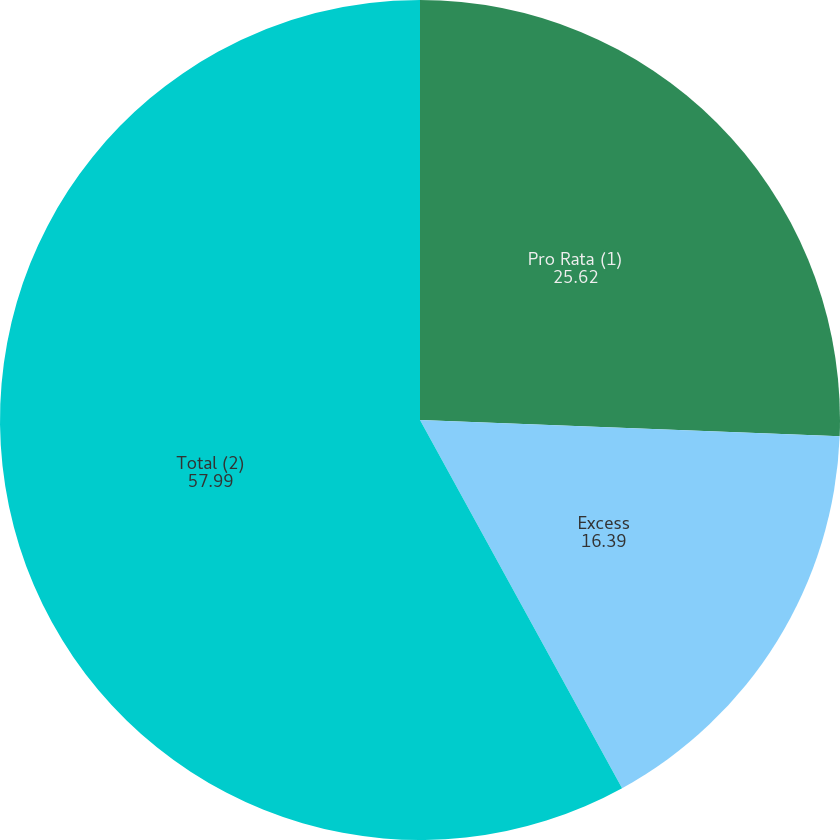Convert chart to OTSL. <chart><loc_0><loc_0><loc_500><loc_500><pie_chart><fcel>Pro Rata (1)<fcel>Excess<fcel>Total (2)<nl><fcel>25.62%<fcel>16.39%<fcel>57.99%<nl></chart> 